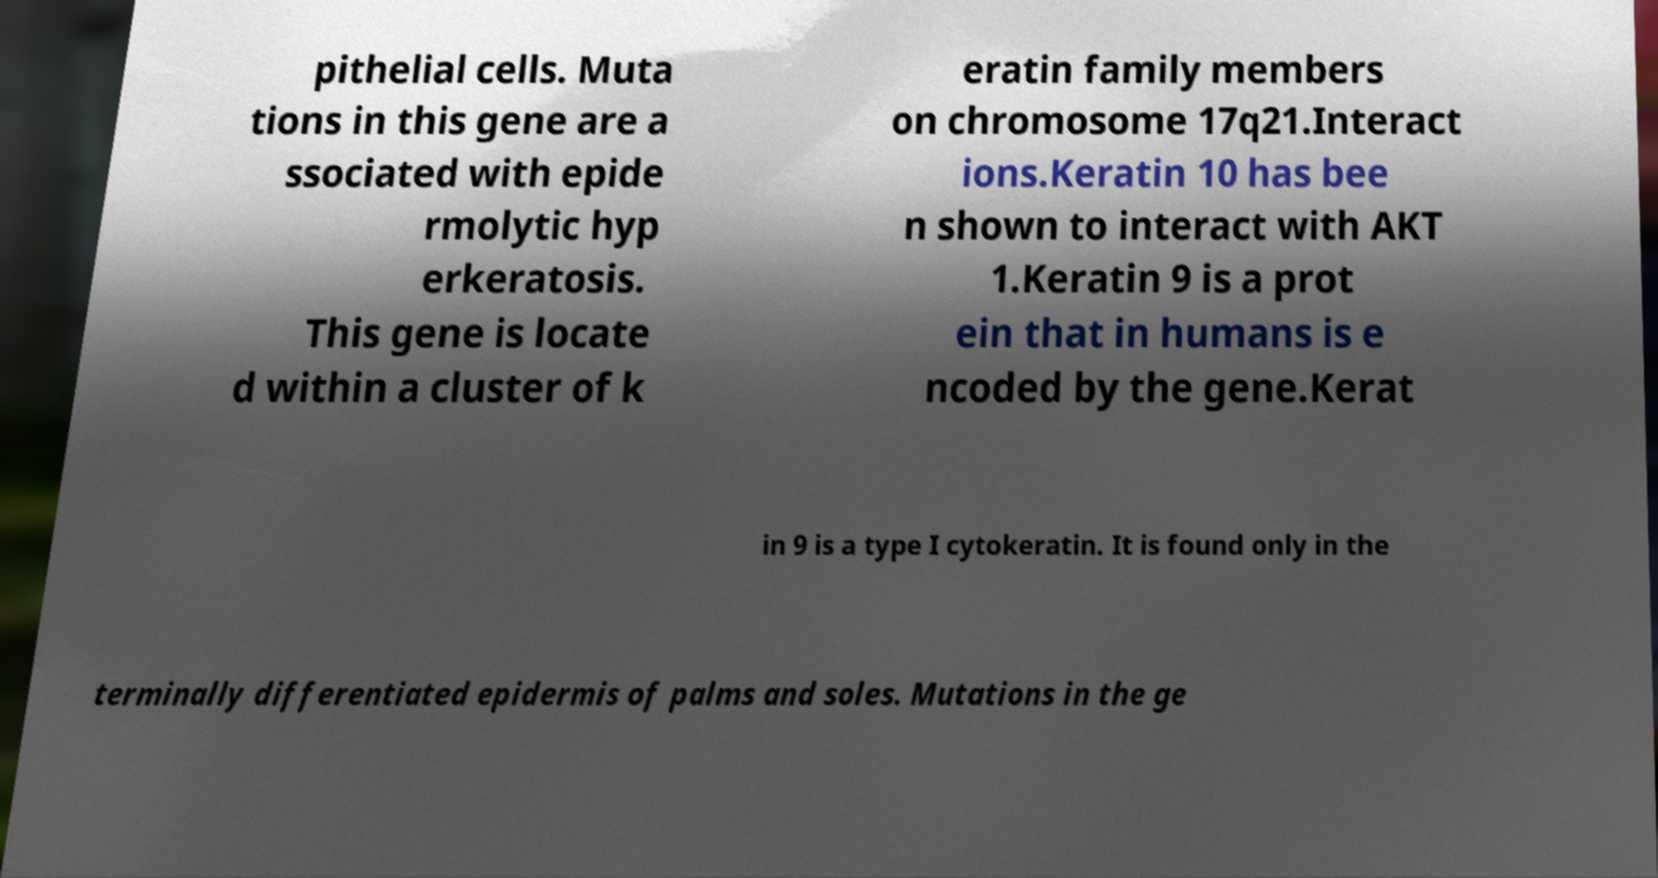What messages or text are displayed in this image? I need them in a readable, typed format. pithelial cells. Muta tions in this gene are a ssociated with epide rmolytic hyp erkeratosis. This gene is locate d within a cluster of k eratin family members on chromosome 17q21.Interact ions.Keratin 10 has bee n shown to interact with AKT 1.Keratin 9 is a prot ein that in humans is e ncoded by the gene.Kerat in 9 is a type I cytokeratin. It is found only in the terminally differentiated epidermis of palms and soles. Mutations in the ge 